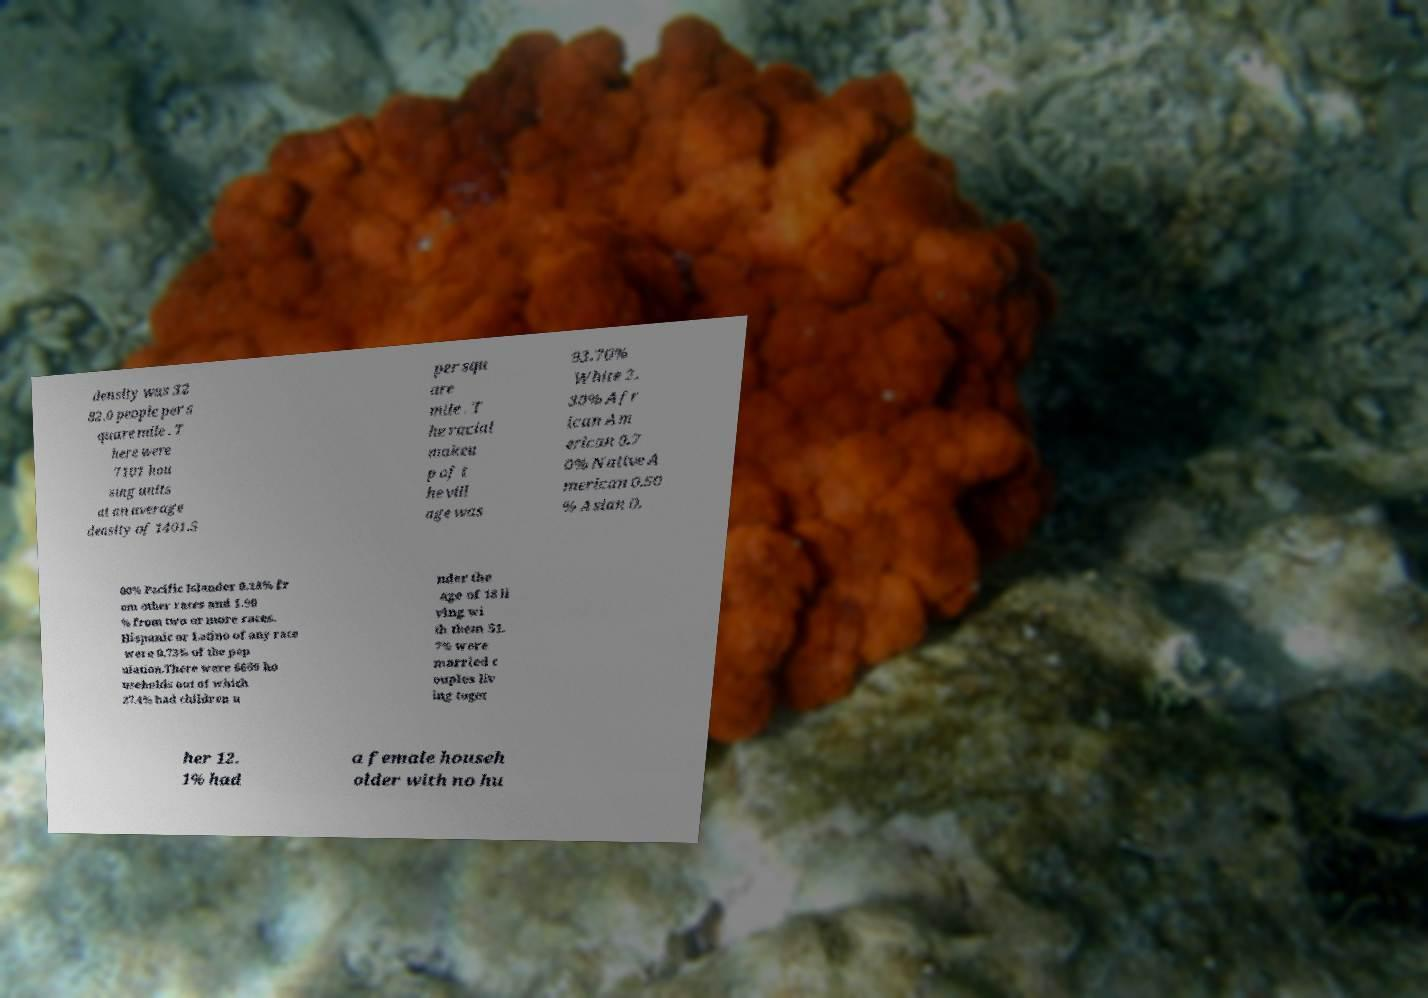Can you accurately transcribe the text from the provided image for me? density was 32 82.0 people per s quare mile . T here were 7101 hou sing units at an average density of 1401.5 per squ are mile . T he racial makeu p of t he vill age was 93.70% White 2. 30% Afr ican Am erican 0.7 0% Native A merican 0.50 % Asian 0. 00% Pacific Islander 0.18% fr om other races and 1.90 % from two or more races. Hispanic or Latino of any race were 0.73% of the pop ulation.There were 6669 ho useholds out of which 27.4% had children u nder the age of 18 li ving wi th them 51. 7% were married c ouples liv ing toget her 12. 1% had a female househ older with no hu 